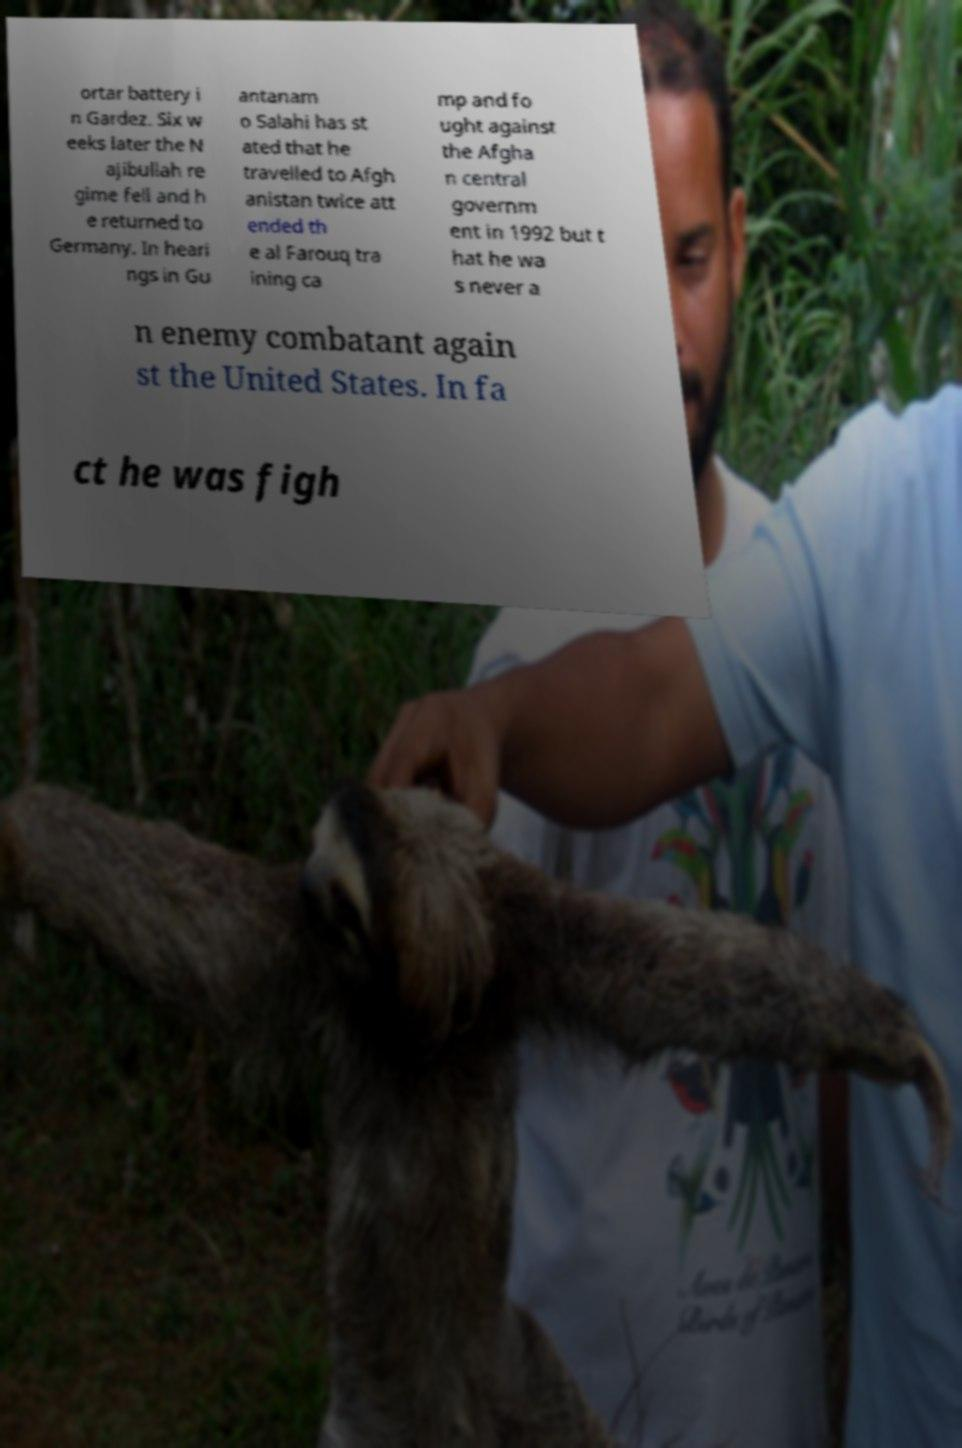Can you accurately transcribe the text from the provided image for me? ortar battery i n Gardez. Six w eeks later the N ajibullah re gime fell and h e returned to Germany. In heari ngs in Gu antanam o Salahi has st ated that he travelled to Afgh anistan twice att ended th e al Farouq tra ining ca mp and fo ught against the Afgha n central governm ent in 1992 but t hat he wa s never a n enemy combatant again st the United States. In fa ct he was figh 